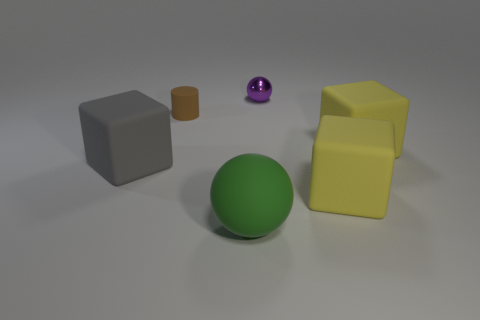Add 3 large red objects. How many objects exist? 9 Subtract all spheres. How many objects are left? 4 Add 1 brown spheres. How many brown spheres exist? 1 Subtract 0 cyan balls. How many objects are left? 6 Subtract all tiny brown matte things. Subtract all large green rubber objects. How many objects are left? 4 Add 4 gray rubber blocks. How many gray rubber blocks are left? 5 